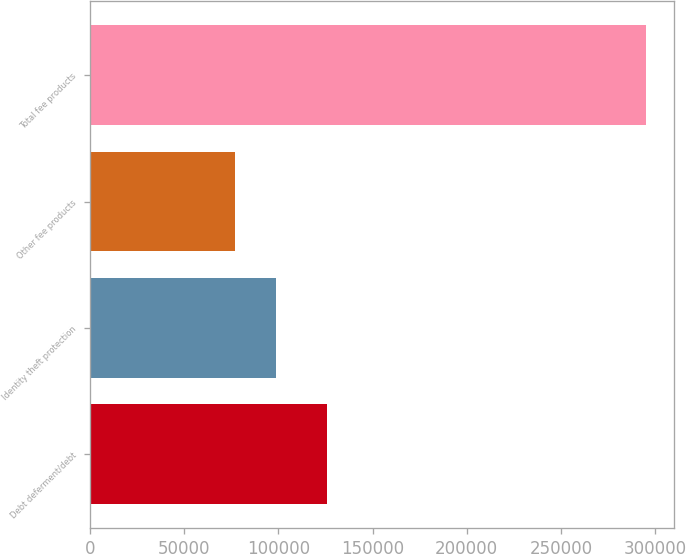<chart> <loc_0><loc_0><loc_500><loc_500><bar_chart><fcel>Debt deferment/debt<fcel>Identity theft protection<fcel>Other fee products<fcel>Total fee products<nl><fcel>125621<fcel>98705.8<fcel>76888<fcel>295066<nl></chart> 